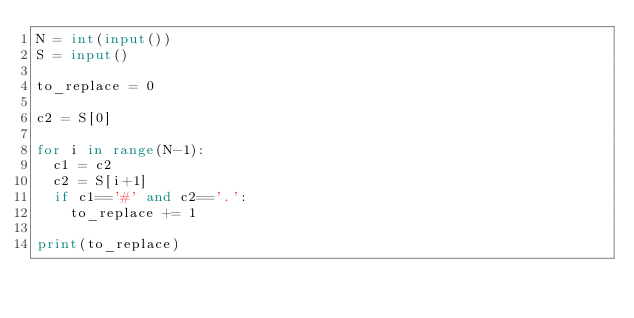Convert code to text. <code><loc_0><loc_0><loc_500><loc_500><_Python_>N = int(input())
S = input()

to_replace = 0

c2 = S[0]

for i in range(N-1):
  c1 = c2
  c2 = S[i+1]
  if c1=='#' and c2=='.':
    to_replace += 1

print(to_replace)</code> 